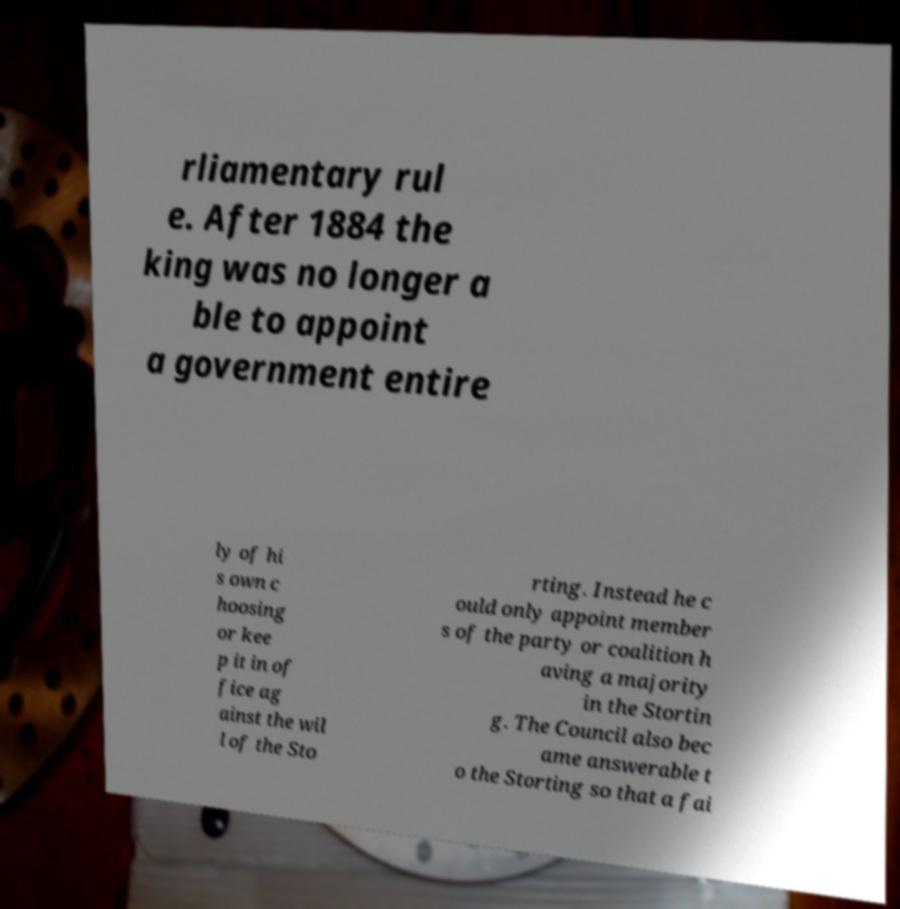Could you extract and type out the text from this image? rliamentary rul e. After 1884 the king was no longer a ble to appoint a government entire ly of hi s own c hoosing or kee p it in of fice ag ainst the wil l of the Sto rting. Instead he c ould only appoint member s of the party or coalition h aving a majority in the Stortin g. The Council also bec ame answerable t o the Storting so that a fai 